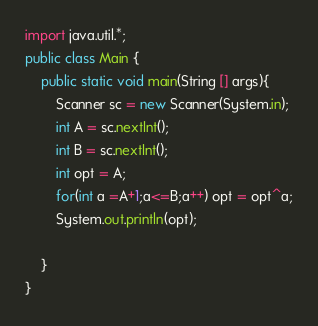<code> <loc_0><loc_0><loc_500><loc_500><_Java_>import java.util.*;
public class Main {
    public static void main(String [] args){
        Scanner sc = new Scanner(System.in);
        int A = sc.nextInt();
        int B = sc.nextInt();
        int opt = A;
        for(int a =A+1;a<=B;a++) opt = opt^a;
        System.out.println(opt);

    }
}</code> 